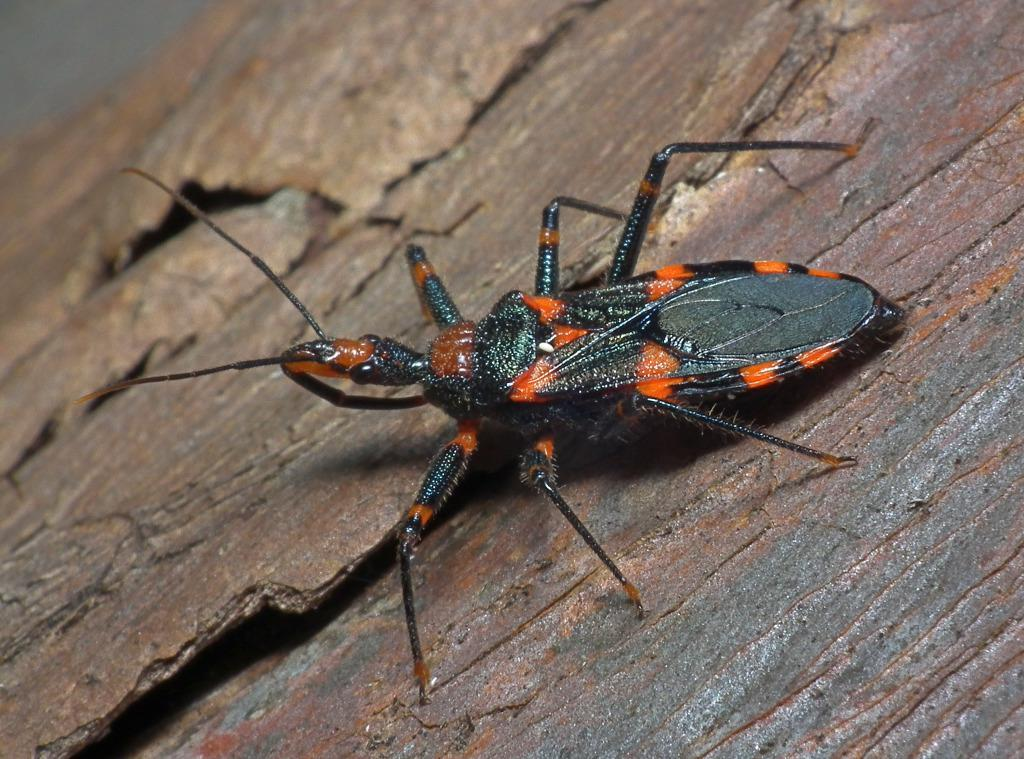What type of creature is present in the image? There is an insect in the image. What colors can be seen on the insect? The insect is black and orange in color. On what surface is the insect located? The insect is on a wooden surface. What type of bed can be seen in the image? There is no bed present in the image; it features an insect on a wooden surface. How many lines are visible on the rake in the image? There is no rake present in the image, so it is not possible to determine the number of lines on a rake. 